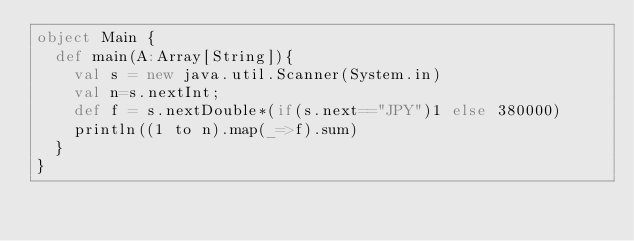<code> <loc_0><loc_0><loc_500><loc_500><_Scala_>object Main {
	def main(A:Array[String]){
		val s = new java.util.Scanner(System.in)
		val n=s.nextInt;
		def f = s.nextDouble*(if(s.next=="JPY")1 else 380000)
		println((1 to n).map(_=>f).sum)
	}
}</code> 